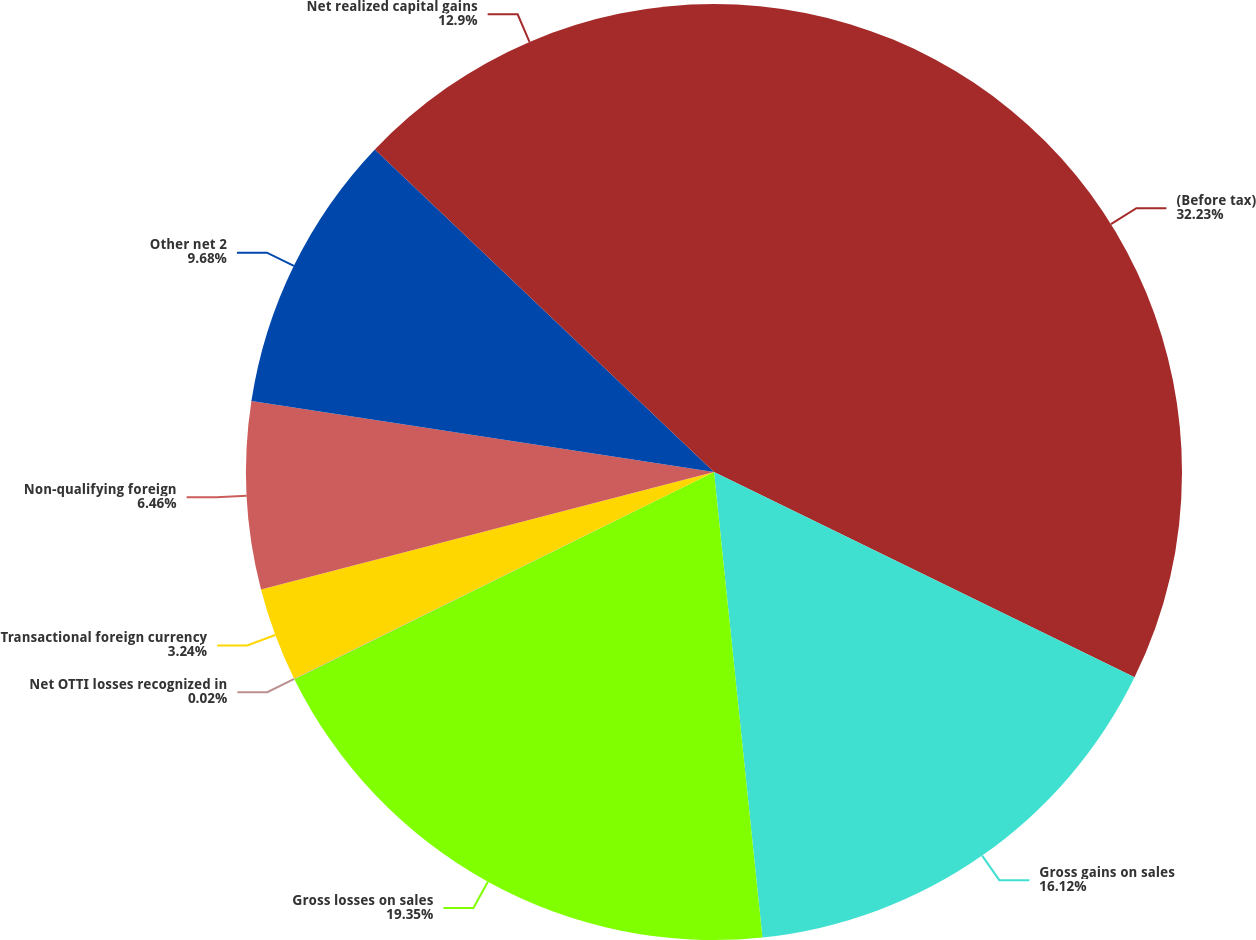Convert chart to OTSL. <chart><loc_0><loc_0><loc_500><loc_500><pie_chart><fcel>(Before tax)<fcel>Gross gains on sales<fcel>Gross losses on sales<fcel>Net OTTI losses recognized in<fcel>Transactional foreign currency<fcel>Non-qualifying foreign<fcel>Other net 2<fcel>Net realized capital gains<nl><fcel>32.23%<fcel>16.12%<fcel>19.35%<fcel>0.02%<fcel>3.24%<fcel>6.46%<fcel>9.68%<fcel>12.9%<nl></chart> 